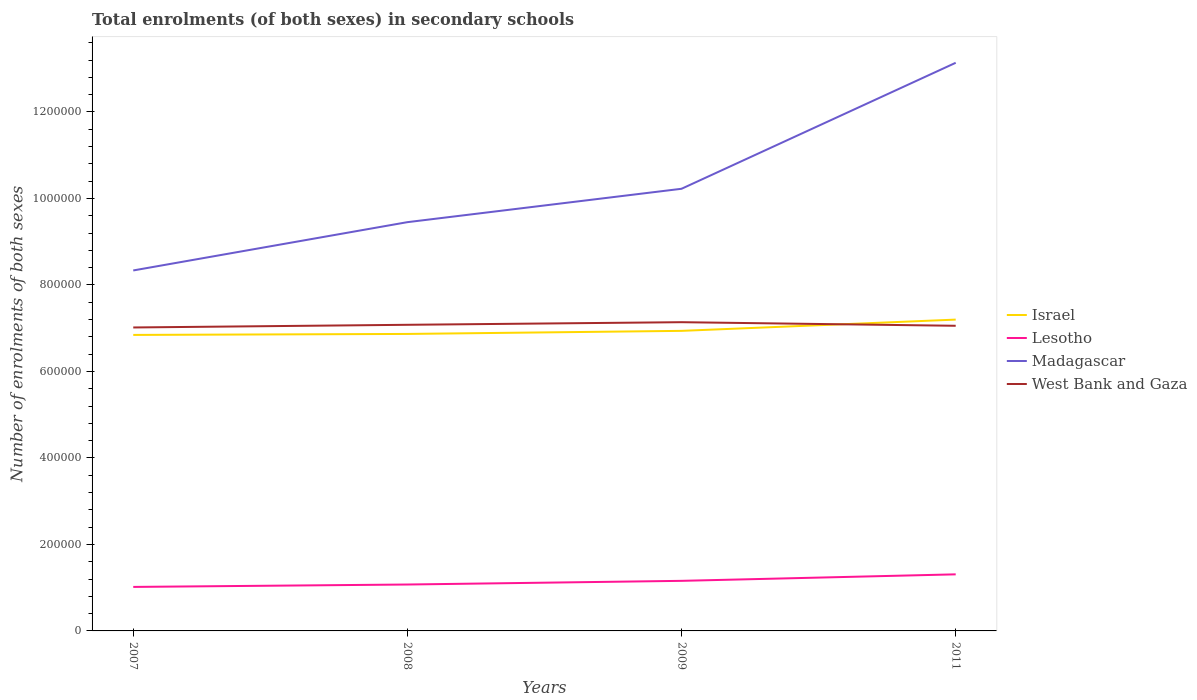Is the number of lines equal to the number of legend labels?
Your response must be concise. Yes. Across all years, what is the maximum number of enrolments in secondary schools in West Bank and Gaza?
Make the answer very short. 7.02e+05. In which year was the number of enrolments in secondary schools in Israel maximum?
Provide a short and direct response. 2007. What is the total number of enrolments in secondary schools in Madagascar in the graph?
Your answer should be compact. -3.69e+05. What is the difference between the highest and the second highest number of enrolments in secondary schools in Madagascar?
Keep it short and to the point. 4.80e+05. Is the number of enrolments in secondary schools in West Bank and Gaza strictly greater than the number of enrolments in secondary schools in Israel over the years?
Make the answer very short. No. How many years are there in the graph?
Ensure brevity in your answer.  4. Does the graph contain any zero values?
Keep it short and to the point. No. Where does the legend appear in the graph?
Keep it short and to the point. Center right. How are the legend labels stacked?
Offer a terse response. Vertical. What is the title of the graph?
Ensure brevity in your answer.  Total enrolments (of both sexes) in secondary schools. What is the label or title of the Y-axis?
Your response must be concise. Number of enrolments of both sexes. What is the Number of enrolments of both sexes in Israel in 2007?
Give a very brief answer. 6.84e+05. What is the Number of enrolments of both sexes in Lesotho in 2007?
Ensure brevity in your answer.  1.02e+05. What is the Number of enrolments of both sexes of Madagascar in 2007?
Give a very brief answer. 8.34e+05. What is the Number of enrolments of both sexes in West Bank and Gaza in 2007?
Your answer should be very brief. 7.02e+05. What is the Number of enrolments of both sexes in Israel in 2008?
Ensure brevity in your answer.  6.87e+05. What is the Number of enrolments of both sexes in Lesotho in 2008?
Keep it short and to the point. 1.07e+05. What is the Number of enrolments of both sexes of Madagascar in 2008?
Provide a succinct answer. 9.45e+05. What is the Number of enrolments of both sexes of West Bank and Gaza in 2008?
Give a very brief answer. 7.08e+05. What is the Number of enrolments of both sexes in Israel in 2009?
Offer a very short reply. 6.94e+05. What is the Number of enrolments of both sexes of Lesotho in 2009?
Keep it short and to the point. 1.16e+05. What is the Number of enrolments of both sexes of Madagascar in 2009?
Your answer should be compact. 1.02e+06. What is the Number of enrolments of both sexes in West Bank and Gaza in 2009?
Keep it short and to the point. 7.14e+05. What is the Number of enrolments of both sexes of Israel in 2011?
Offer a very short reply. 7.20e+05. What is the Number of enrolments of both sexes of Lesotho in 2011?
Give a very brief answer. 1.31e+05. What is the Number of enrolments of both sexes in Madagascar in 2011?
Provide a succinct answer. 1.31e+06. What is the Number of enrolments of both sexes of West Bank and Gaza in 2011?
Your response must be concise. 7.06e+05. Across all years, what is the maximum Number of enrolments of both sexes in Israel?
Offer a very short reply. 7.20e+05. Across all years, what is the maximum Number of enrolments of both sexes in Lesotho?
Your response must be concise. 1.31e+05. Across all years, what is the maximum Number of enrolments of both sexes of Madagascar?
Provide a succinct answer. 1.31e+06. Across all years, what is the maximum Number of enrolments of both sexes in West Bank and Gaza?
Ensure brevity in your answer.  7.14e+05. Across all years, what is the minimum Number of enrolments of both sexes in Israel?
Your answer should be very brief. 6.84e+05. Across all years, what is the minimum Number of enrolments of both sexes in Lesotho?
Make the answer very short. 1.02e+05. Across all years, what is the minimum Number of enrolments of both sexes of Madagascar?
Offer a very short reply. 8.34e+05. Across all years, what is the minimum Number of enrolments of both sexes in West Bank and Gaza?
Your answer should be compact. 7.02e+05. What is the total Number of enrolments of both sexes in Israel in the graph?
Provide a succinct answer. 2.79e+06. What is the total Number of enrolments of both sexes in Lesotho in the graph?
Your answer should be compact. 4.56e+05. What is the total Number of enrolments of both sexes in Madagascar in the graph?
Your answer should be very brief. 4.12e+06. What is the total Number of enrolments of both sexes of West Bank and Gaza in the graph?
Provide a short and direct response. 2.83e+06. What is the difference between the Number of enrolments of both sexes of Israel in 2007 and that in 2008?
Your answer should be very brief. -2299. What is the difference between the Number of enrolments of both sexes in Lesotho in 2007 and that in 2008?
Provide a succinct answer. -5584. What is the difference between the Number of enrolments of both sexes of Madagascar in 2007 and that in 2008?
Your answer should be compact. -1.12e+05. What is the difference between the Number of enrolments of both sexes in West Bank and Gaza in 2007 and that in 2008?
Ensure brevity in your answer.  -6177. What is the difference between the Number of enrolments of both sexes of Israel in 2007 and that in 2009?
Provide a succinct answer. -9399. What is the difference between the Number of enrolments of both sexes of Lesotho in 2007 and that in 2009?
Offer a very short reply. -1.41e+04. What is the difference between the Number of enrolments of both sexes of Madagascar in 2007 and that in 2009?
Make the answer very short. -1.89e+05. What is the difference between the Number of enrolments of both sexes of West Bank and Gaza in 2007 and that in 2009?
Provide a succinct answer. -1.22e+04. What is the difference between the Number of enrolments of both sexes of Israel in 2007 and that in 2011?
Offer a terse response. -3.54e+04. What is the difference between the Number of enrolments of both sexes in Lesotho in 2007 and that in 2011?
Ensure brevity in your answer.  -2.91e+04. What is the difference between the Number of enrolments of both sexes of Madagascar in 2007 and that in 2011?
Provide a succinct answer. -4.80e+05. What is the difference between the Number of enrolments of both sexes of West Bank and Gaza in 2007 and that in 2011?
Provide a short and direct response. -3912. What is the difference between the Number of enrolments of both sexes in Israel in 2008 and that in 2009?
Provide a short and direct response. -7100. What is the difference between the Number of enrolments of both sexes in Lesotho in 2008 and that in 2009?
Offer a very short reply. -8483. What is the difference between the Number of enrolments of both sexes of Madagascar in 2008 and that in 2009?
Provide a succinct answer. -7.72e+04. What is the difference between the Number of enrolments of both sexes of West Bank and Gaza in 2008 and that in 2009?
Offer a very short reply. -6029. What is the difference between the Number of enrolments of both sexes of Israel in 2008 and that in 2011?
Your answer should be compact. -3.31e+04. What is the difference between the Number of enrolments of both sexes of Lesotho in 2008 and that in 2011?
Your answer should be very brief. -2.35e+04. What is the difference between the Number of enrolments of both sexes in Madagascar in 2008 and that in 2011?
Your response must be concise. -3.69e+05. What is the difference between the Number of enrolments of both sexes of West Bank and Gaza in 2008 and that in 2011?
Your answer should be very brief. 2265. What is the difference between the Number of enrolments of both sexes in Israel in 2009 and that in 2011?
Give a very brief answer. -2.60e+04. What is the difference between the Number of enrolments of both sexes in Lesotho in 2009 and that in 2011?
Give a very brief answer. -1.50e+04. What is the difference between the Number of enrolments of both sexes of Madagascar in 2009 and that in 2011?
Offer a very short reply. -2.91e+05. What is the difference between the Number of enrolments of both sexes of West Bank and Gaza in 2009 and that in 2011?
Ensure brevity in your answer.  8294. What is the difference between the Number of enrolments of both sexes of Israel in 2007 and the Number of enrolments of both sexes of Lesotho in 2008?
Provide a succinct answer. 5.77e+05. What is the difference between the Number of enrolments of both sexes of Israel in 2007 and the Number of enrolments of both sexes of Madagascar in 2008?
Your answer should be compact. -2.61e+05. What is the difference between the Number of enrolments of both sexes of Israel in 2007 and the Number of enrolments of both sexes of West Bank and Gaza in 2008?
Make the answer very short. -2.34e+04. What is the difference between the Number of enrolments of both sexes of Lesotho in 2007 and the Number of enrolments of both sexes of Madagascar in 2008?
Keep it short and to the point. -8.44e+05. What is the difference between the Number of enrolments of both sexes in Lesotho in 2007 and the Number of enrolments of both sexes in West Bank and Gaza in 2008?
Your answer should be compact. -6.06e+05. What is the difference between the Number of enrolments of both sexes in Madagascar in 2007 and the Number of enrolments of both sexes in West Bank and Gaza in 2008?
Your response must be concise. 1.26e+05. What is the difference between the Number of enrolments of both sexes of Israel in 2007 and the Number of enrolments of both sexes of Lesotho in 2009?
Provide a succinct answer. 5.69e+05. What is the difference between the Number of enrolments of both sexes in Israel in 2007 and the Number of enrolments of both sexes in Madagascar in 2009?
Make the answer very short. -3.38e+05. What is the difference between the Number of enrolments of both sexes of Israel in 2007 and the Number of enrolments of both sexes of West Bank and Gaza in 2009?
Your answer should be compact. -2.94e+04. What is the difference between the Number of enrolments of both sexes of Lesotho in 2007 and the Number of enrolments of both sexes of Madagascar in 2009?
Offer a terse response. -9.21e+05. What is the difference between the Number of enrolments of both sexes of Lesotho in 2007 and the Number of enrolments of both sexes of West Bank and Gaza in 2009?
Provide a succinct answer. -6.12e+05. What is the difference between the Number of enrolments of both sexes in Madagascar in 2007 and the Number of enrolments of both sexes in West Bank and Gaza in 2009?
Your answer should be compact. 1.20e+05. What is the difference between the Number of enrolments of both sexes of Israel in 2007 and the Number of enrolments of both sexes of Lesotho in 2011?
Make the answer very short. 5.54e+05. What is the difference between the Number of enrolments of both sexes in Israel in 2007 and the Number of enrolments of both sexes in Madagascar in 2011?
Provide a short and direct response. -6.29e+05. What is the difference between the Number of enrolments of both sexes of Israel in 2007 and the Number of enrolments of both sexes of West Bank and Gaza in 2011?
Provide a short and direct response. -2.11e+04. What is the difference between the Number of enrolments of both sexes in Lesotho in 2007 and the Number of enrolments of both sexes in Madagascar in 2011?
Your answer should be very brief. -1.21e+06. What is the difference between the Number of enrolments of both sexes in Lesotho in 2007 and the Number of enrolments of both sexes in West Bank and Gaza in 2011?
Give a very brief answer. -6.04e+05. What is the difference between the Number of enrolments of both sexes of Madagascar in 2007 and the Number of enrolments of both sexes of West Bank and Gaza in 2011?
Ensure brevity in your answer.  1.28e+05. What is the difference between the Number of enrolments of both sexes in Israel in 2008 and the Number of enrolments of both sexes in Lesotho in 2009?
Your answer should be compact. 5.71e+05. What is the difference between the Number of enrolments of both sexes in Israel in 2008 and the Number of enrolments of both sexes in Madagascar in 2009?
Make the answer very short. -3.36e+05. What is the difference between the Number of enrolments of both sexes of Israel in 2008 and the Number of enrolments of both sexes of West Bank and Gaza in 2009?
Provide a short and direct response. -2.71e+04. What is the difference between the Number of enrolments of both sexes in Lesotho in 2008 and the Number of enrolments of both sexes in Madagascar in 2009?
Keep it short and to the point. -9.15e+05. What is the difference between the Number of enrolments of both sexes of Lesotho in 2008 and the Number of enrolments of both sexes of West Bank and Gaza in 2009?
Offer a terse response. -6.07e+05. What is the difference between the Number of enrolments of both sexes of Madagascar in 2008 and the Number of enrolments of both sexes of West Bank and Gaza in 2009?
Give a very brief answer. 2.31e+05. What is the difference between the Number of enrolments of both sexes of Israel in 2008 and the Number of enrolments of both sexes of Lesotho in 2011?
Make the answer very short. 5.56e+05. What is the difference between the Number of enrolments of both sexes in Israel in 2008 and the Number of enrolments of both sexes in Madagascar in 2011?
Your answer should be very brief. -6.27e+05. What is the difference between the Number of enrolments of both sexes of Israel in 2008 and the Number of enrolments of both sexes of West Bank and Gaza in 2011?
Your answer should be very brief. -1.88e+04. What is the difference between the Number of enrolments of both sexes in Lesotho in 2008 and the Number of enrolments of both sexes in Madagascar in 2011?
Offer a very short reply. -1.21e+06. What is the difference between the Number of enrolments of both sexes in Lesotho in 2008 and the Number of enrolments of both sexes in West Bank and Gaza in 2011?
Provide a short and direct response. -5.98e+05. What is the difference between the Number of enrolments of both sexes in Madagascar in 2008 and the Number of enrolments of both sexes in West Bank and Gaza in 2011?
Offer a very short reply. 2.40e+05. What is the difference between the Number of enrolments of both sexes of Israel in 2009 and the Number of enrolments of both sexes of Lesotho in 2011?
Your response must be concise. 5.63e+05. What is the difference between the Number of enrolments of both sexes in Israel in 2009 and the Number of enrolments of both sexes in Madagascar in 2011?
Provide a succinct answer. -6.20e+05. What is the difference between the Number of enrolments of both sexes of Israel in 2009 and the Number of enrolments of both sexes of West Bank and Gaza in 2011?
Provide a succinct answer. -1.18e+04. What is the difference between the Number of enrolments of both sexes in Lesotho in 2009 and the Number of enrolments of both sexes in Madagascar in 2011?
Your answer should be compact. -1.20e+06. What is the difference between the Number of enrolments of both sexes of Lesotho in 2009 and the Number of enrolments of both sexes of West Bank and Gaza in 2011?
Offer a very short reply. -5.90e+05. What is the difference between the Number of enrolments of both sexes in Madagascar in 2009 and the Number of enrolments of both sexes in West Bank and Gaza in 2011?
Ensure brevity in your answer.  3.17e+05. What is the average Number of enrolments of both sexes of Israel per year?
Keep it short and to the point. 6.96e+05. What is the average Number of enrolments of both sexes in Lesotho per year?
Your answer should be very brief. 1.14e+05. What is the average Number of enrolments of both sexes of Madagascar per year?
Provide a succinct answer. 1.03e+06. What is the average Number of enrolments of both sexes of West Bank and Gaza per year?
Offer a terse response. 7.07e+05. In the year 2007, what is the difference between the Number of enrolments of both sexes in Israel and Number of enrolments of both sexes in Lesotho?
Your answer should be compact. 5.83e+05. In the year 2007, what is the difference between the Number of enrolments of both sexes of Israel and Number of enrolments of both sexes of Madagascar?
Make the answer very short. -1.49e+05. In the year 2007, what is the difference between the Number of enrolments of both sexes of Israel and Number of enrolments of both sexes of West Bank and Gaza?
Your answer should be very brief. -1.72e+04. In the year 2007, what is the difference between the Number of enrolments of both sexes in Lesotho and Number of enrolments of both sexes in Madagascar?
Make the answer very short. -7.32e+05. In the year 2007, what is the difference between the Number of enrolments of both sexes in Lesotho and Number of enrolments of both sexes in West Bank and Gaza?
Offer a very short reply. -6.00e+05. In the year 2007, what is the difference between the Number of enrolments of both sexes in Madagascar and Number of enrolments of both sexes in West Bank and Gaza?
Offer a very short reply. 1.32e+05. In the year 2008, what is the difference between the Number of enrolments of both sexes in Israel and Number of enrolments of both sexes in Lesotho?
Offer a very short reply. 5.79e+05. In the year 2008, what is the difference between the Number of enrolments of both sexes in Israel and Number of enrolments of both sexes in Madagascar?
Give a very brief answer. -2.58e+05. In the year 2008, what is the difference between the Number of enrolments of both sexes of Israel and Number of enrolments of both sexes of West Bank and Gaza?
Keep it short and to the point. -2.11e+04. In the year 2008, what is the difference between the Number of enrolments of both sexes of Lesotho and Number of enrolments of both sexes of Madagascar?
Provide a short and direct response. -8.38e+05. In the year 2008, what is the difference between the Number of enrolments of both sexes of Lesotho and Number of enrolments of both sexes of West Bank and Gaza?
Ensure brevity in your answer.  -6.01e+05. In the year 2008, what is the difference between the Number of enrolments of both sexes in Madagascar and Number of enrolments of both sexes in West Bank and Gaza?
Give a very brief answer. 2.37e+05. In the year 2009, what is the difference between the Number of enrolments of both sexes in Israel and Number of enrolments of both sexes in Lesotho?
Your answer should be very brief. 5.78e+05. In the year 2009, what is the difference between the Number of enrolments of both sexes of Israel and Number of enrolments of both sexes of Madagascar?
Provide a short and direct response. -3.29e+05. In the year 2009, what is the difference between the Number of enrolments of both sexes of Israel and Number of enrolments of both sexes of West Bank and Gaza?
Offer a very short reply. -2.00e+04. In the year 2009, what is the difference between the Number of enrolments of both sexes of Lesotho and Number of enrolments of both sexes of Madagascar?
Offer a very short reply. -9.07e+05. In the year 2009, what is the difference between the Number of enrolments of both sexes in Lesotho and Number of enrolments of both sexes in West Bank and Gaza?
Offer a terse response. -5.98e+05. In the year 2009, what is the difference between the Number of enrolments of both sexes in Madagascar and Number of enrolments of both sexes in West Bank and Gaza?
Your response must be concise. 3.09e+05. In the year 2011, what is the difference between the Number of enrolments of both sexes in Israel and Number of enrolments of both sexes in Lesotho?
Ensure brevity in your answer.  5.89e+05. In the year 2011, what is the difference between the Number of enrolments of both sexes in Israel and Number of enrolments of both sexes in Madagascar?
Provide a succinct answer. -5.94e+05. In the year 2011, what is the difference between the Number of enrolments of both sexes in Israel and Number of enrolments of both sexes in West Bank and Gaza?
Offer a very short reply. 1.43e+04. In the year 2011, what is the difference between the Number of enrolments of both sexes of Lesotho and Number of enrolments of both sexes of Madagascar?
Give a very brief answer. -1.18e+06. In the year 2011, what is the difference between the Number of enrolments of both sexes of Lesotho and Number of enrolments of both sexes of West Bank and Gaza?
Your response must be concise. -5.75e+05. In the year 2011, what is the difference between the Number of enrolments of both sexes of Madagascar and Number of enrolments of both sexes of West Bank and Gaza?
Provide a succinct answer. 6.08e+05. What is the ratio of the Number of enrolments of both sexes in Israel in 2007 to that in 2008?
Give a very brief answer. 1. What is the ratio of the Number of enrolments of both sexes of Lesotho in 2007 to that in 2008?
Provide a short and direct response. 0.95. What is the ratio of the Number of enrolments of both sexes of Madagascar in 2007 to that in 2008?
Your answer should be very brief. 0.88. What is the ratio of the Number of enrolments of both sexes in West Bank and Gaza in 2007 to that in 2008?
Provide a short and direct response. 0.99. What is the ratio of the Number of enrolments of both sexes in Israel in 2007 to that in 2009?
Provide a short and direct response. 0.99. What is the ratio of the Number of enrolments of both sexes in Lesotho in 2007 to that in 2009?
Offer a terse response. 0.88. What is the ratio of the Number of enrolments of both sexes of Madagascar in 2007 to that in 2009?
Your answer should be compact. 0.82. What is the ratio of the Number of enrolments of both sexes in West Bank and Gaza in 2007 to that in 2009?
Make the answer very short. 0.98. What is the ratio of the Number of enrolments of both sexes of Israel in 2007 to that in 2011?
Provide a short and direct response. 0.95. What is the ratio of the Number of enrolments of both sexes of Lesotho in 2007 to that in 2011?
Your answer should be very brief. 0.78. What is the ratio of the Number of enrolments of both sexes in Madagascar in 2007 to that in 2011?
Make the answer very short. 0.63. What is the ratio of the Number of enrolments of both sexes of West Bank and Gaza in 2007 to that in 2011?
Your answer should be compact. 0.99. What is the ratio of the Number of enrolments of both sexes of Lesotho in 2008 to that in 2009?
Your response must be concise. 0.93. What is the ratio of the Number of enrolments of both sexes in Madagascar in 2008 to that in 2009?
Offer a very short reply. 0.92. What is the ratio of the Number of enrolments of both sexes of Israel in 2008 to that in 2011?
Make the answer very short. 0.95. What is the ratio of the Number of enrolments of both sexes in Lesotho in 2008 to that in 2011?
Give a very brief answer. 0.82. What is the ratio of the Number of enrolments of both sexes in Madagascar in 2008 to that in 2011?
Ensure brevity in your answer.  0.72. What is the ratio of the Number of enrolments of both sexes of West Bank and Gaza in 2008 to that in 2011?
Give a very brief answer. 1. What is the ratio of the Number of enrolments of both sexes in Israel in 2009 to that in 2011?
Ensure brevity in your answer.  0.96. What is the ratio of the Number of enrolments of both sexes in Lesotho in 2009 to that in 2011?
Keep it short and to the point. 0.89. What is the ratio of the Number of enrolments of both sexes of Madagascar in 2009 to that in 2011?
Offer a very short reply. 0.78. What is the ratio of the Number of enrolments of both sexes of West Bank and Gaza in 2009 to that in 2011?
Ensure brevity in your answer.  1.01. What is the difference between the highest and the second highest Number of enrolments of both sexes of Israel?
Offer a terse response. 2.60e+04. What is the difference between the highest and the second highest Number of enrolments of both sexes in Lesotho?
Ensure brevity in your answer.  1.50e+04. What is the difference between the highest and the second highest Number of enrolments of both sexes of Madagascar?
Offer a terse response. 2.91e+05. What is the difference between the highest and the second highest Number of enrolments of both sexes of West Bank and Gaza?
Your answer should be compact. 6029. What is the difference between the highest and the lowest Number of enrolments of both sexes of Israel?
Keep it short and to the point. 3.54e+04. What is the difference between the highest and the lowest Number of enrolments of both sexes in Lesotho?
Ensure brevity in your answer.  2.91e+04. What is the difference between the highest and the lowest Number of enrolments of both sexes in Madagascar?
Keep it short and to the point. 4.80e+05. What is the difference between the highest and the lowest Number of enrolments of both sexes in West Bank and Gaza?
Make the answer very short. 1.22e+04. 